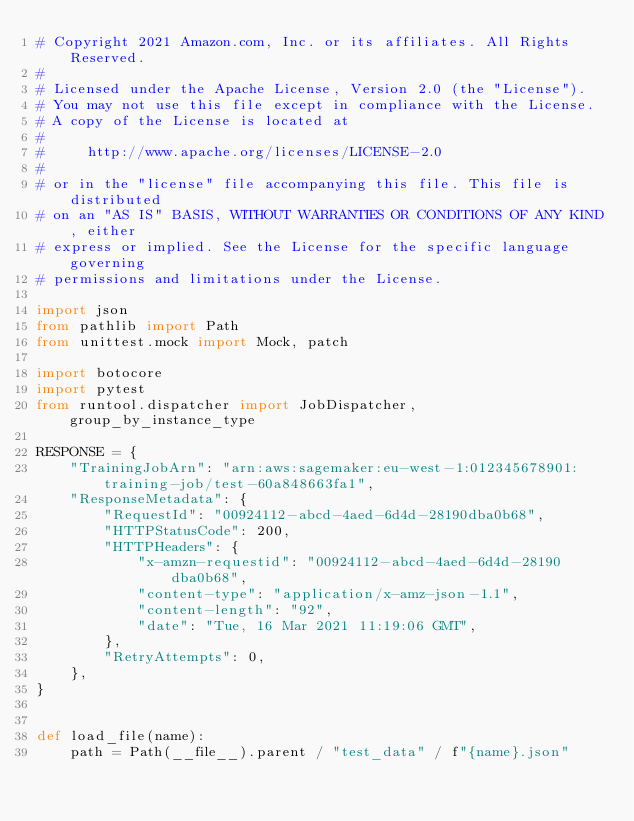<code> <loc_0><loc_0><loc_500><loc_500><_Python_># Copyright 2021 Amazon.com, Inc. or its affiliates. All Rights Reserved.
#
# Licensed under the Apache License, Version 2.0 (the "License").
# You may not use this file except in compliance with the License.
# A copy of the License is located at
#
#     http://www.apache.org/licenses/LICENSE-2.0
#
# or in the "license" file accompanying this file. This file is distributed
# on an "AS IS" BASIS, WITHOUT WARRANTIES OR CONDITIONS OF ANY KIND, either
# express or implied. See the License for the specific language governing
# permissions and limitations under the License.

import json
from pathlib import Path
from unittest.mock import Mock, patch

import botocore
import pytest
from runtool.dispatcher import JobDispatcher, group_by_instance_type

RESPONSE = {
    "TrainingJobArn": "arn:aws:sagemaker:eu-west-1:012345678901:training-job/test-60a848663fa1",
    "ResponseMetadata": {
        "RequestId": "00924112-abcd-4aed-6d4d-28190dba0b68",
        "HTTPStatusCode": 200,
        "HTTPHeaders": {
            "x-amzn-requestid": "00924112-abcd-4aed-6d4d-28190dba0b68",
            "content-type": "application/x-amz-json-1.1",
            "content-length": "92",
            "date": "Tue, 16 Mar 2021 11:19:06 GMT",
        },
        "RetryAttempts": 0,
    },
}


def load_file(name):
    path = Path(__file__).parent / "test_data" / f"{name}.json"</code> 